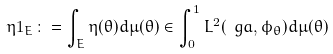<formula> <loc_0><loc_0><loc_500><loc_500>\eta 1 _ { E } \colon = \int _ { E } \eta ( \theta ) d \mu ( \theta ) \in \int _ { 0 } ^ { 1 } L ^ { 2 } ( \ g a , \phi _ { \theta } ) d \mu ( \theta )</formula> 